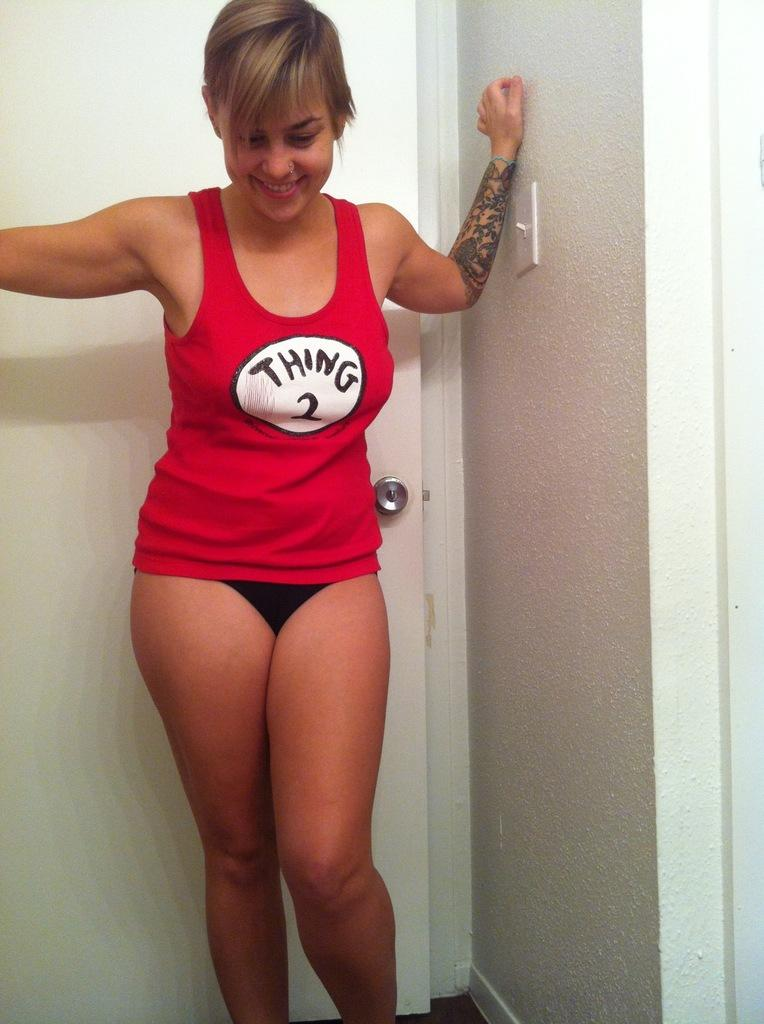Provide a one-sentence caption for the provided image. Girl is posing in a thing two shirt and black underwear. 